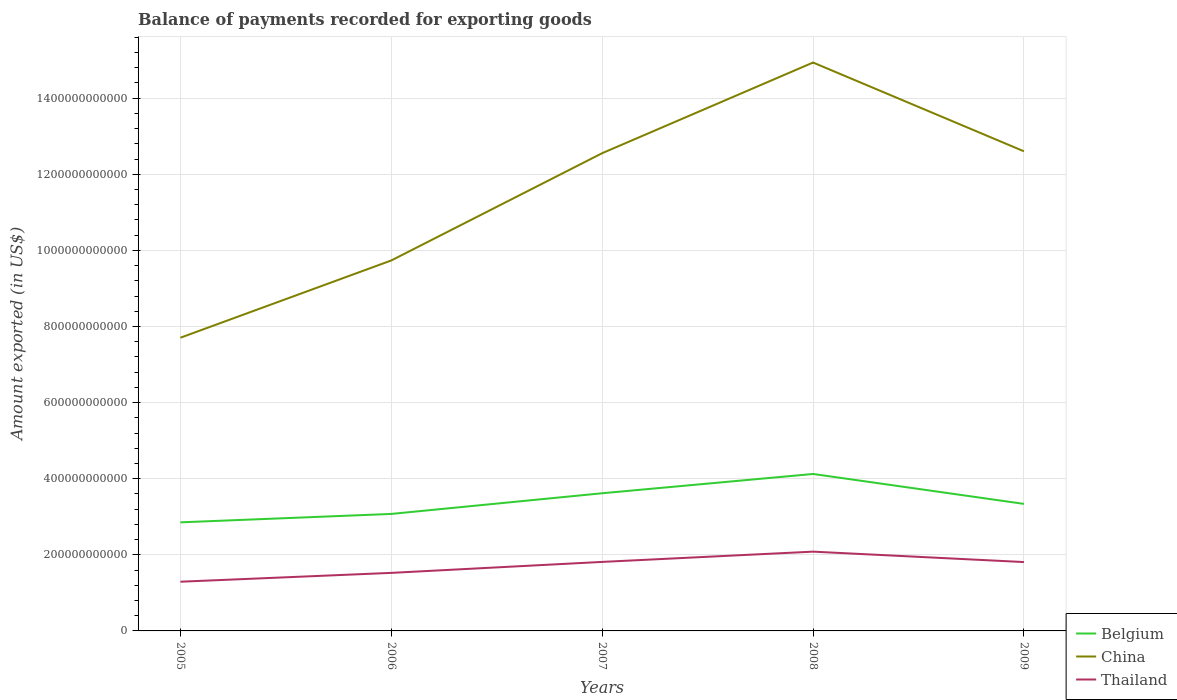How many different coloured lines are there?
Provide a short and direct response. 3. Across all years, what is the maximum amount exported in China?
Your response must be concise. 7.70e+11. What is the total amount exported in Belgium in the graph?
Ensure brevity in your answer.  -2.21e+1. What is the difference between the highest and the second highest amount exported in Belgium?
Offer a terse response. 1.27e+11. Is the amount exported in Belgium strictly greater than the amount exported in China over the years?
Ensure brevity in your answer.  Yes. How many years are there in the graph?
Offer a very short reply. 5. What is the difference between two consecutive major ticks on the Y-axis?
Provide a succinct answer. 2.00e+11. Are the values on the major ticks of Y-axis written in scientific E-notation?
Offer a very short reply. No. Does the graph contain any zero values?
Offer a terse response. No. Where does the legend appear in the graph?
Keep it short and to the point. Bottom right. How many legend labels are there?
Make the answer very short. 3. What is the title of the graph?
Provide a succinct answer. Balance of payments recorded for exporting goods. Does "Saudi Arabia" appear as one of the legend labels in the graph?
Your answer should be compact. No. What is the label or title of the X-axis?
Offer a very short reply. Years. What is the label or title of the Y-axis?
Your answer should be very brief. Amount exported (in US$). What is the Amount exported (in US$) of Belgium in 2005?
Ensure brevity in your answer.  2.85e+11. What is the Amount exported (in US$) of China in 2005?
Provide a succinct answer. 7.70e+11. What is the Amount exported (in US$) of Thailand in 2005?
Your response must be concise. 1.29e+11. What is the Amount exported (in US$) of Belgium in 2006?
Your response must be concise. 3.07e+11. What is the Amount exported (in US$) of China in 2006?
Provide a short and direct response. 9.73e+11. What is the Amount exported (in US$) of Thailand in 2006?
Provide a succinct answer. 1.53e+11. What is the Amount exported (in US$) in Belgium in 2007?
Offer a very short reply. 3.62e+11. What is the Amount exported (in US$) of China in 2007?
Your response must be concise. 1.26e+12. What is the Amount exported (in US$) in Thailand in 2007?
Ensure brevity in your answer.  1.81e+11. What is the Amount exported (in US$) in Belgium in 2008?
Your response must be concise. 4.12e+11. What is the Amount exported (in US$) in China in 2008?
Offer a terse response. 1.49e+12. What is the Amount exported (in US$) in Thailand in 2008?
Keep it short and to the point. 2.08e+11. What is the Amount exported (in US$) of Belgium in 2009?
Ensure brevity in your answer.  3.34e+11. What is the Amount exported (in US$) in China in 2009?
Give a very brief answer. 1.26e+12. What is the Amount exported (in US$) in Thailand in 2009?
Offer a very short reply. 1.81e+11. Across all years, what is the maximum Amount exported (in US$) in Belgium?
Offer a very short reply. 4.12e+11. Across all years, what is the maximum Amount exported (in US$) in China?
Provide a short and direct response. 1.49e+12. Across all years, what is the maximum Amount exported (in US$) of Thailand?
Give a very brief answer. 2.08e+11. Across all years, what is the minimum Amount exported (in US$) in Belgium?
Make the answer very short. 2.85e+11. Across all years, what is the minimum Amount exported (in US$) in China?
Offer a terse response. 7.70e+11. Across all years, what is the minimum Amount exported (in US$) in Thailand?
Your answer should be compact. 1.29e+11. What is the total Amount exported (in US$) of Belgium in the graph?
Your response must be concise. 1.70e+12. What is the total Amount exported (in US$) of China in the graph?
Offer a very short reply. 5.75e+12. What is the total Amount exported (in US$) in Thailand in the graph?
Make the answer very short. 8.52e+11. What is the difference between the Amount exported (in US$) of Belgium in 2005 and that in 2006?
Make the answer very short. -2.21e+1. What is the difference between the Amount exported (in US$) in China in 2005 and that in 2006?
Provide a succinct answer. -2.03e+11. What is the difference between the Amount exported (in US$) in Thailand in 2005 and that in 2006?
Provide a short and direct response. -2.32e+1. What is the difference between the Amount exported (in US$) of Belgium in 2005 and that in 2007?
Your response must be concise. -7.65e+1. What is the difference between the Amount exported (in US$) of China in 2005 and that in 2007?
Your answer should be compact. -4.85e+11. What is the difference between the Amount exported (in US$) of Thailand in 2005 and that in 2007?
Provide a short and direct response. -5.21e+1. What is the difference between the Amount exported (in US$) of Belgium in 2005 and that in 2008?
Provide a short and direct response. -1.27e+11. What is the difference between the Amount exported (in US$) of China in 2005 and that in 2008?
Your answer should be very brief. -7.23e+11. What is the difference between the Amount exported (in US$) in Thailand in 2005 and that in 2008?
Ensure brevity in your answer.  -7.90e+1. What is the difference between the Amount exported (in US$) of Belgium in 2005 and that in 2009?
Your answer should be compact. -4.85e+1. What is the difference between the Amount exported (in US$) of China in 2005 and that in 2009?
Offer a terse response. -4.90e+11. What is the difference between the Amount exported (in US$) in Thailand in 2005 and that in 2009?
Make the answer very short. -5.17e+1. What is the difference between the Amount exported (in US$) in Belgium in 2006 and that in 2007?
Make the answer very short. -5.44e+1. What is the difference between the Amount exported (in US$) in China in 2006 and that in 2007?
Your response must be concise. -2.82e+11. What is the difference between the Amount exported (in US$) in Thailand in 2006 and that in 2007?
Your response must be concise. -2.88e+1. What is the difference between the Amount exported (in US$) of Belgium in 2006 and that in 2008?
Provide a succinct answer. -1.05e+11. What is the difference between the Amount exported (in US$) in China in 2006 and that in 2008?
Ensure brevity in your answer.  -5.20e+11. What is the difference between the Amount exported (in US$) of Thailand in 2006 and that in 2008?
Provide a succinct answer. -5.58e+1. What is the difference between the Amount exported (in US$) of Belgium in 2006 and that in 2009?
Provide a succinct answer. -2.64e+1. What is the difference between the Amount exported (in US$) of China in 2006 and that in 2009?
Make the answer very short. -2.87e+11. What is the difference between the Amount exported (in US$) of Thailand in 2006 and that in 2009?
Your response must be concise. -2.84e+1. What is the difference between the Amount exported (in US$) of Belgium in 2007 and that in 2008?
Provide a succinct answer. -5.07e+1. What is the difference between the Amount exported (in US$) of China in 2007 and that in 2008?
Provide a short and direct response. -2.38e+11. What is the difference between the Amount exported (in US$) in Thailand in 2007 and that in 2008?
Provide a succinct answer. -2.70e+1. What is the difference between the Amount exported (in US$) of Belgium in 2007 and that in 2009?
Ensure brevity in your answer.  2.79e+1. What is the difference between the Amount exported (in US$) in China in 2007 and that in 2009?
Provide a succinct answer. -4.97e+09. What is the difference between the Amount exported (in US$) of Thailand in 2007 and that in 2009?
Provide a succinct answer. 4.05e+08. What is the difference between the Amount exported (in US$) in Belgium in 2008 and that in 2009?
Your response must be concise. 7.86e+1. What is the difference between the Amount exported (in US$) of China in 2008 and that in 2009?
Provide a succinct answer. 2.33e+11. What is the difference between the Amount exported (in US$) of Thailand in 2008 and that in 2009?
Keep it short and to the point. 2.74e+1. What is the difference between the Amount exported (in US$) in Belgium in 2005 and the Amount exported (in US$) in China in 2006?
Give a very brief answer. -6.88e+11. What is the difference between the Amount exported (in US$) in Belgium in 2005 and the Amount exported (in US$) in Thailand in 2006?
Give a very brief answer. 1.33e+11. What is the difference between the Amount exported (in US$) in China in 2005 and the Amount exported (in US$) in Thailand in 2006?
Provide a succinct answer. 6.18e+11. What is the difference between the Amount exported (in US$) in Belgium in 2005 and the Amount exported (in US$) in China in 2007?
Give a very brief answer. -9.70e+11. What is the difference between the Amount exported (in US$) of Belgium in 2005 and the Amount exported (in US$) of Thailand in 2007?
Offer a very short reply. 1.04e+11. What is the difference between the Amount exported (in US$) in China in 2005 and the Amount exported (in US$) in Thailand in 2007?
Make the answer very short. 5.89e+11. What is the difference between the Amount exported (in US$) in Belgium in 2005 and the Amount exported (in US$) in China in 2008?
Offer a terse response. -1.21e+12. What is the difference between the Amount exported (in US$) in Belgium in 2005 and the Amount exported (in US$) in Thailand in 2008?
Provide a short and direct response. 7.70e+1. What is the difference between the Amount exported (in US$) of China in 2005 and the Amount exported (in US$) of Thailand in 2008?
Provide a succinct answer. 5.62e+11. What is the difference between the Amount exported (in US$) in Belgium in 2005 and the Amount exported (in US$) in China in 2009?
Offer a very short reply. -9.75e+11. What is the difference between the Amount exported (in US$) in Belgium in 2005 and the Amount exported (in US$) in Thailand in 2009?
Provide a succinct answer. 1.04e+11. What is the difference between the Amount exported (in US$) in China in 2005 and the Amount exported (in US$) in Thailand in 2009?
Make the answer very short. 5.90e+11. What is the difference between the Amount exported (in US$) of Belgium in 2006 and the Amount exported (in US$) of China in 2007?
Make the answer very short. -9.48e+11. What is the difference between the Amount exported (in US$) of Belgium in 2006 and the Amount exported (in US$) of Thailand in 2007?
Make the answer very short. 1.26e+11. What is the difference between the Amount exported (in US$) in China in 2006 and the Amount exported (in US$) in Thailand in 2007?
Your response must be concise. 7.92e+11. What is the difference between the Amount exported (in US$) in Belgium in 2006 and the Amount exported (in US$) in China in 2008?
Provide a succinct answer. -1.19e+12. What is the difference between the Amount exported (in US$) in Belgium in 2006 and the Amount exported (in US$) in Thailand in 2008?
Provide a short and direct response. 9.91e+1. What is the difference between the Amount exported (in US$) in China in 2006 and the Amount exported (in US$) in Thailand in 2008?
Ensure brevity in your answer.  7.65e+11. What is the difference between the Amount exported (in US$) of Belgium in 2006 and the Amount exported (in US$) of China in 2009?
Ensure brevity in your answer.  -9.53e+11. What is the difference between the Amount exported (in US$) of Belgium in 2006 and the Amount exported (in US$) of Thailand in 2009?
Provide a short and direct response. 1.26e+11. What is the difference between the Amount exported (in US$) in China in 2006 and the Amount exported (in US$) in Thailand in 2009?
Ensure brevity in your answer.  7.93e+11. What is the difference between the Amount exported (in US$) in Belgium in 2007 and the Amount exported (in US$) in China in 2008?
Keep it short and to the point. -1.13e+12. What is the difference between the Amount exported (in US$) in Belgium in 2007 and the Amount exported (in US$) in Thailand in 2008?
Offer a terse response. 1.53e+11. What is the difference between the Amount exported (in US$) in China in 2007 and the Amount exported (in US$) in Thailand in 2008?
Provide a short and direct response. 1.05e+12. What is the difference between the Amount exported (in US$) of Belgium in 2007 and the Amount exported (in US$) of China in 2009?
Keep it short and to the point. -8.99e+11. What is the difference between the Amount exported (in US$) of Belgium in 2007 and the Amount exported (in US$) of Thailand in 2009?
Your response must be concise. 1.81e+11. What is the difference between the Amount exported (in US$) of China in 2007 and the Amount exported (in US$) of Thailand in 2009?
Give a very brief answer. 1.07e+12. What is the difference between the Amount exported (in US$) in Belgium in 2008 and the Amount exported (in US$) in China in 2009?
Your response must be concise. -8.48e+11. What is the difference between the Amount exported (in US$) in Belgium in 2008 and the Amount exported (in US$) in Thailand in 2009?
Give a very brief answer. 2.31e+11. What is the difference between the Amount exported (in US$) of China in 2008 and the Amount exported (in US$) of Thailand in 2009?
Keep it short and to the point. 1.31e+12. What is the average Amount exported (in US$) of Belgium per year?
Offer a terse response. 3.40e+11. What is the average Amount exported (in US$) in China per year?
Your answer should be very brief. 1.15e+12. What is the average Amount exported (in US$) of Thailand per year?
Offer a terse response. 1.70e+11. In the year 2005, what is the difference between the Amount exported (in US$) of Belgium and Amount exported (in US$) of China?
Ensure brevity in your answer.  -4.85e+11. In the year 2005, what is the difference between the Amount exported (in US$) of Belgium and Amount exported (in US$) of Thailand?
Offer a terse response. 1.56e+11. In the year 2005, what is the difference between the Amount exported (in US$) in China and Amount exported (in US$) in Thailand?
Your answer should be very brief. 6.41e+11. In the year 2006, what is the difference between the Amount exported (in US$) in Belgium and Amount exported (in US$) in China?
Your answer should be compact. -6.66e+11. In the year 2006, what is the difference between the Amount exported (in US$) of Belgium and Amount exported (in US$) of Thailand?
Make the answer very short. 1.55e+11. In the year 2006, what is the difference between the Amount exported (in US$) of China and Amount exported (in US$) of Thailand?
Your response must be concise. 8.21e+11. In the year 2007, what is the difference between the Amount exported (in US$) in Belgium and Amount exported (in US$) in China?
Keep it short and to the point. -8.94e+11. In the year 2007, what is the difference between the Amount exported (in US$) of Belgium and Amount exported (in US$) of Thailand?
Your response must be concise. 1.80e+11. In the year 2007, what is the difference between the Amount exported (in US$) in China and Amount exported (in US$) in Thailand?
Ensure brevity in your answer.  1.07e+12. In the year 2008, what is the difference between the Amount exported (in US$) of Belgium and Amount exported (in US$) of China?
Ensure brevity in your answer.  -1.08e+12. In the year 2008, what is the difference between the Amount exported (in US$) in Belgium and Amount exported (in US$) in Thailand?
Offer a very short reply. 2.04e+11. In the year 2008, what is the difference between the Amount exported (in US$) of China and Amount exported (in US$) of Thailand?
Provide a succinct answer. 1.29e+12. In the year 2009, what is the difference between the Amount exported (in US$) in Belgium and Amount exported (in US$) in China?
Offer a terse response. -9.26e+11. In the year 2009, what is the difference between the Amount exported (in US$) in Belgium and Amount exported (in US$) in Thailand?
Offer a very short reply. 1.53e+11. In the year 2009, what is the difference between the Amount exported (in US$) in China and Amount exported (in US$) in Thailand?
Your answer should be very brief. 1.08e+12. What is the ratio of the Amount exported (in US$) in Belgium in 2005 to that in 2006?
Ensure brevity in your answer.  0.93. What is the ratio of the Amount exported (in US$) of China in 2005 to that in 2006?
Provide a short and direct response. 0.79. What is the ratio of the Amount exported (in US$) in Thailand in 2005 to that in 2006?
Offer a terse response. 0.85. What is the ratio of the Amount exported (in US$) in Belgium in 2005 to that in 2007?
Ensure brevity in your answer.  0.79. What is the ratio of the Amount exported (in US$) in China in 2005 to that in 2007?
Keep it short and to the point. 0.61. What is the ratio of the Amount exported (in US$) of Thailand in 2005 to that in 2007?
Your answer should be compact. 0.71. What is the ratio of the Amount exported (in US$) of Belgium in 2005 to that in 2008?
Offer a terse response. 0.69. What is the ratio of the Amount exported (in US$) in China in 2005 to that in 2008?
Give a very brief answer. 0.52. What is the ratio of the Amount exported (in US$) of Thailand in 2005 to that in 2008?
Your answer should be compact. 0.62. What is the ratio of the Amount exported (in US$) in Belgium in 2005 to that in 2009?
Offer a terse response. 0.85. What is the ratio of the Amount exported (in US$) in China in 2005 to that in 2009?
Ensure brevity in your answer.  0.61. What is the ratio of the Amount exported (in US$) of Thailand in 2005 to that in 2009?
Make the answer very short. 0.71. What is the ratio of the Amount exported (in US$) in Belgium in 2006 to that in 2007?
Offer a very short reply. 0.85. What is the ratio of the Amount exported (in US$) of China in 2006 to that in 2007?
Provide a succinct answer. 0.78. What is the ratio of the Amount exported (in US$) of Thailand in 2006 to that in 2007?
Your response must be concise. 0.84. What is the ratio of the Amount exported (in US$) in Belgium in 2006 to that in 2008?
Ensure brevity in your answer.  0.75. What is the ratio of the Amount exported (in US$) in China in 2006 to that in 2008?
Your answer should be very brief. 0.65. What is the ratio of the Amount exported (in US$) of Thailand in 2006 to that in 2008?
Provide a succinct answer. 0.73. What is the ratio of the Amount exported (in US$) of Belgium in 2006 to that in 2009?
Provide a short and direct response. 0.92. What is the ratio of the Amount exported (in US$) of China in 2006 to that in 2009?
Provide a short and direct response. 0.77. What is the ratio of the Amount exported (in US$) in Thailand in 2006 to that in 2009?
Your response must be concise. 0.84. What is the ratio of the Amount exported (in US$) of Belgium in 2007 to that in 2008?
Offer a very short reply. 0.88. What is the ratio of the Amount exported (in US$) in China in 2007 to that in 2008?
Offer a terse response. 0.84. What is the ratio of the Amount exported (in US$) of Thailand in 2007 to that in 2008?
Offer a very short reply. 0.87. What is the ratio of the Amount exported (in US$) in Belgium in 2007 to that in 2009?
Your answer should be very brief. 1.08. What is the ratio of the Amount exported (in US$) in Belgium in 2008 to that in 2009?
Ensure brevity in your answer.  1.24. What is the ratio of the Amount exported (in US$) in China in 2008 to that in 2009?
Your answer should be compact. 1.19. What is the ratio of the Amount exported (in US$) in Thailand in 2008 to that in 2009?
Provide a succinct answer. 1.15. What is the difference between the highest and the second highest Amount exported (in US$) of Belgium?
Ensure brevity in your answer.  5.07e+1. What is the difference between the highest and the second highest Amount exported (in US$) of China?
Provide a succinct answer. 2.33e+11. What is the difference between the highest and the second highest Amount exported (in US$) in Thailand?
Provide a short and direct response. 2.70e+1. What is the difference between the highest and the lowest Amount exported (in US$) in Belgium?
Make the answer very short. 1.27e+11. What is the difference between the highest and the lowest Amount exported (in US$) in China?
Your answer should be very brief. 7.23e+11. What is the difference between the highest and the lowest Amount exported (in US$) in Thailand?
Make the answer very short. 7.90e+1. 